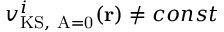<formula> <loc_0><loc_0><loc_500><loc_500>{ v _ { K S , A = 0 } ^ { i } ( r ) } \neq { c o n s t }</formula> 